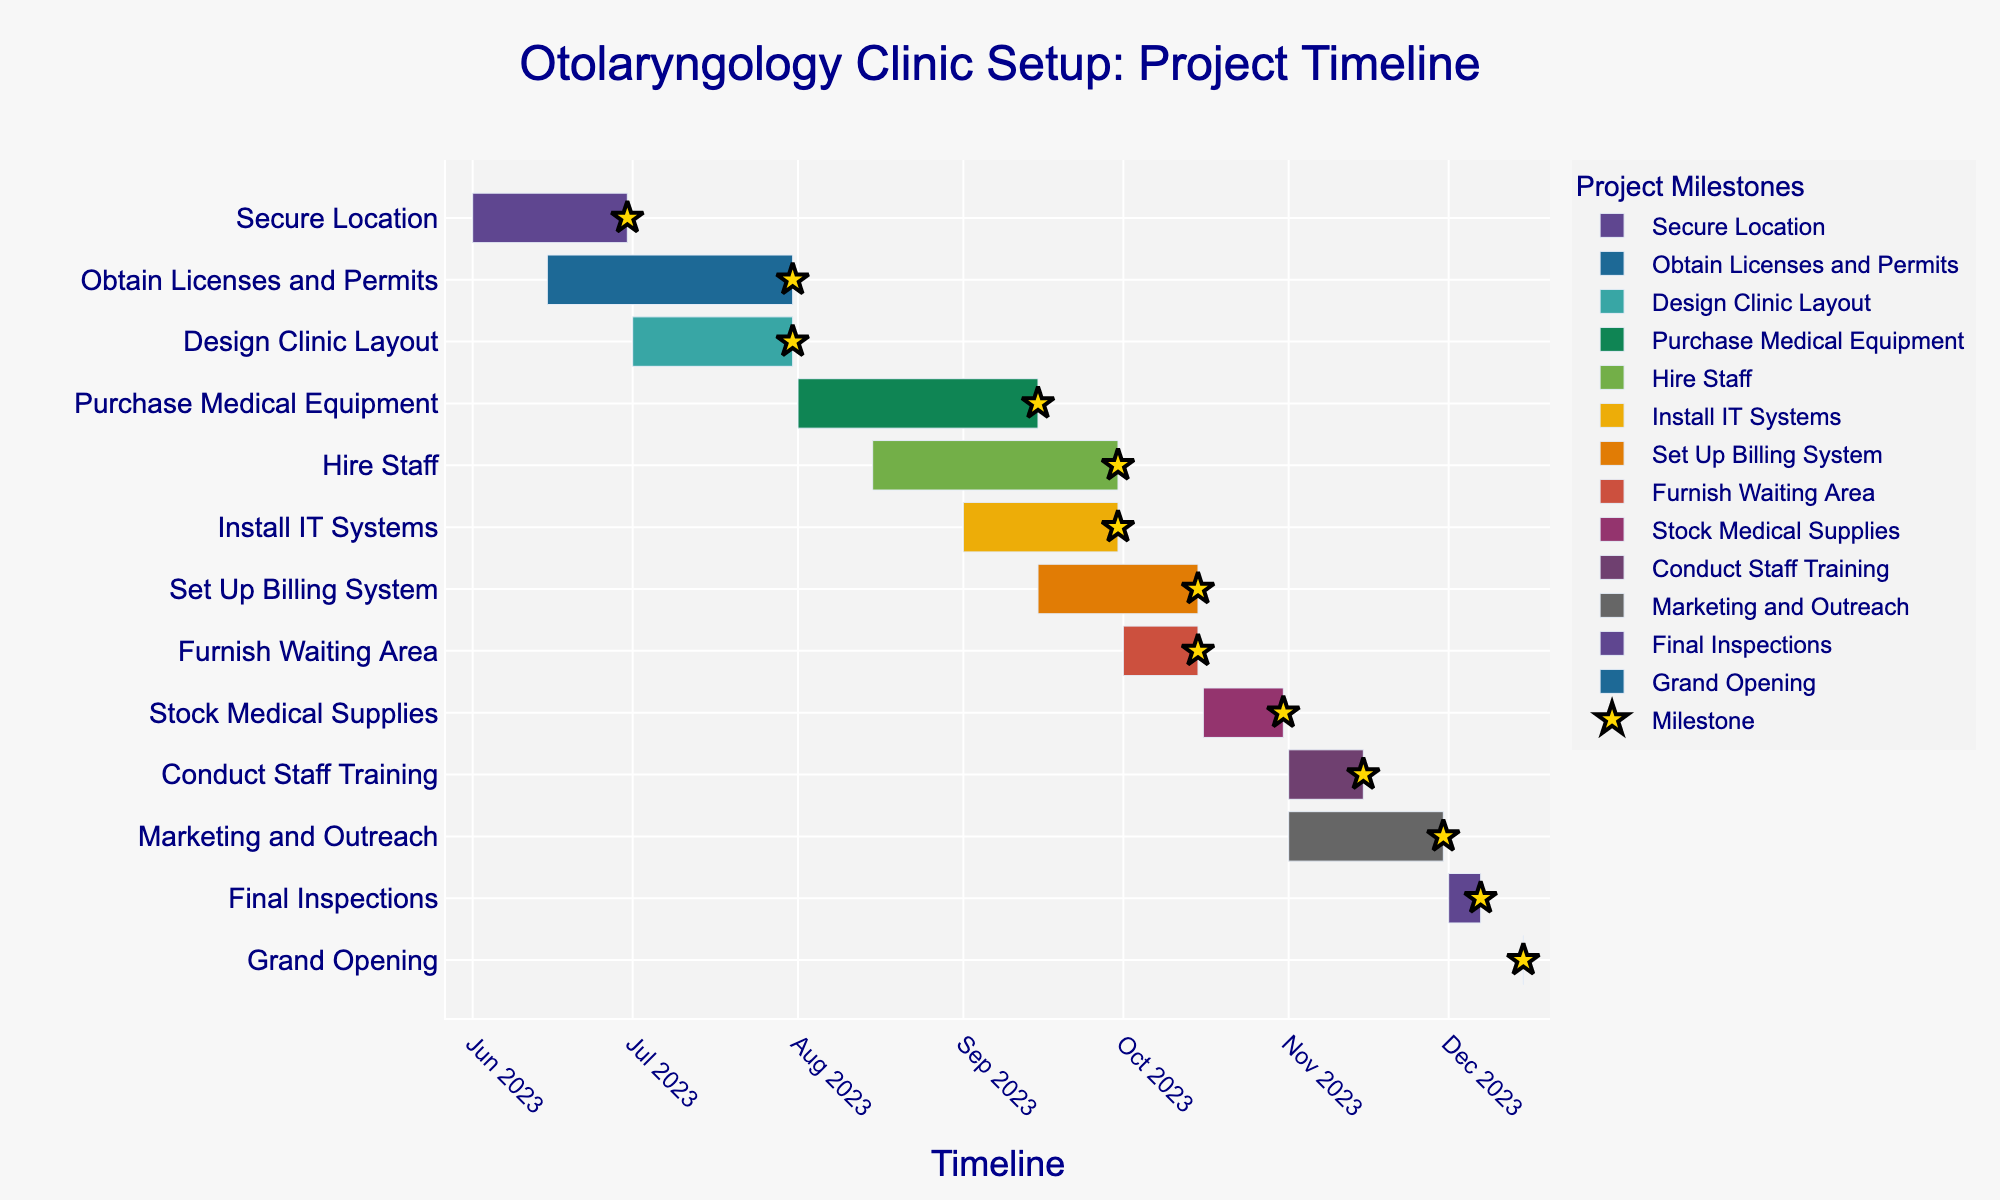Which task has the shortest duration? The task with the shortest duration can be identified by looking at the length of the bars on the Gantt chart. The shortest bar will represent the task with the shortest duration. In this case, "Grand Opening" has the shortest duration as it spans only one day.
Answer: Grand Opening Which tasks are scheduled to start in November? To identify tasks starting in November, look at the x-axis and locate November. Then, check which tasks' start dates fall within this month. Both "Conduct Staff Training" and "Marketing and Outreach" start in November.
Answer: Conduct Staff Training, Marketing and Outreach How long is the total duration from the start of the first task to the end of the last task? Calculate the difference between the start date of the first task, "Secure Location" (June 1, 2023), and the end date of the last task, "Grand Opening" (December 15, 2023). This can be done by counting the number of days between these dates.
Answer: 197 days Which task overlaps the most with "Hire Staff"? Find "Hire Staff" on the chart and check other bars that overlap with this task. "Purchase Medical Equipment" and "Install IT Systems" overlap with "Hire Staff". To see the one with the greatest overlap duration, compare their overlapping periods. "Install IT Systems" overlaps significantly with "Hire Staff".
Answer: Install IT Systems Which tasks are scheduled to end on or before September 30, 2023? Locate September 30, 2023, on the x-axis and identify the bars ending on or before this date. "Secure Location", "Obtain Licenses and Permits", "Design Clinic Layout", "Purchase Medical Equipment", and "Install IT Systems" end on or before September 30, 2023.
Answer: Secure Location, Obtain Licenses and Permits, Design Clinic Layout, Purchase Medical Equipment, Install IT Systems What is the average duration of the tasks ending in October? Identify tasks ending in October: "Set Up Billing System" (October 15, 31 days), "Furnish Waiting Area" (October 15, 15 days), and "Stock Medical Supplies" (October 31, 16 days). Add their durations (31 + 15 + 16) and divide by the number of tasks (3). The average is (31 + 15 + 16) / 3 = 62 / 3 = 20.67
Answer: 20.67 days Which two tasks have the same duration? Look for bars of equal lengths on the chart and verify their durations in days. "Hire Staff" and "Obtain Licenses and Permits" both have durations of 47 days.
Answer: Hire Staff, Obtain Licenses and Permits When is the earliest that "Final Inspections" can start? For "Final Inspections" to start, all dependent tasks must be completed. Look for tasks ending before or on the start date of "Final Inspections". Since there are no direct dependencies shown, "Final Inspections" starts immediately after preceding tasks. It starts on December 1, 2023.
Answer: December 1, 2023 